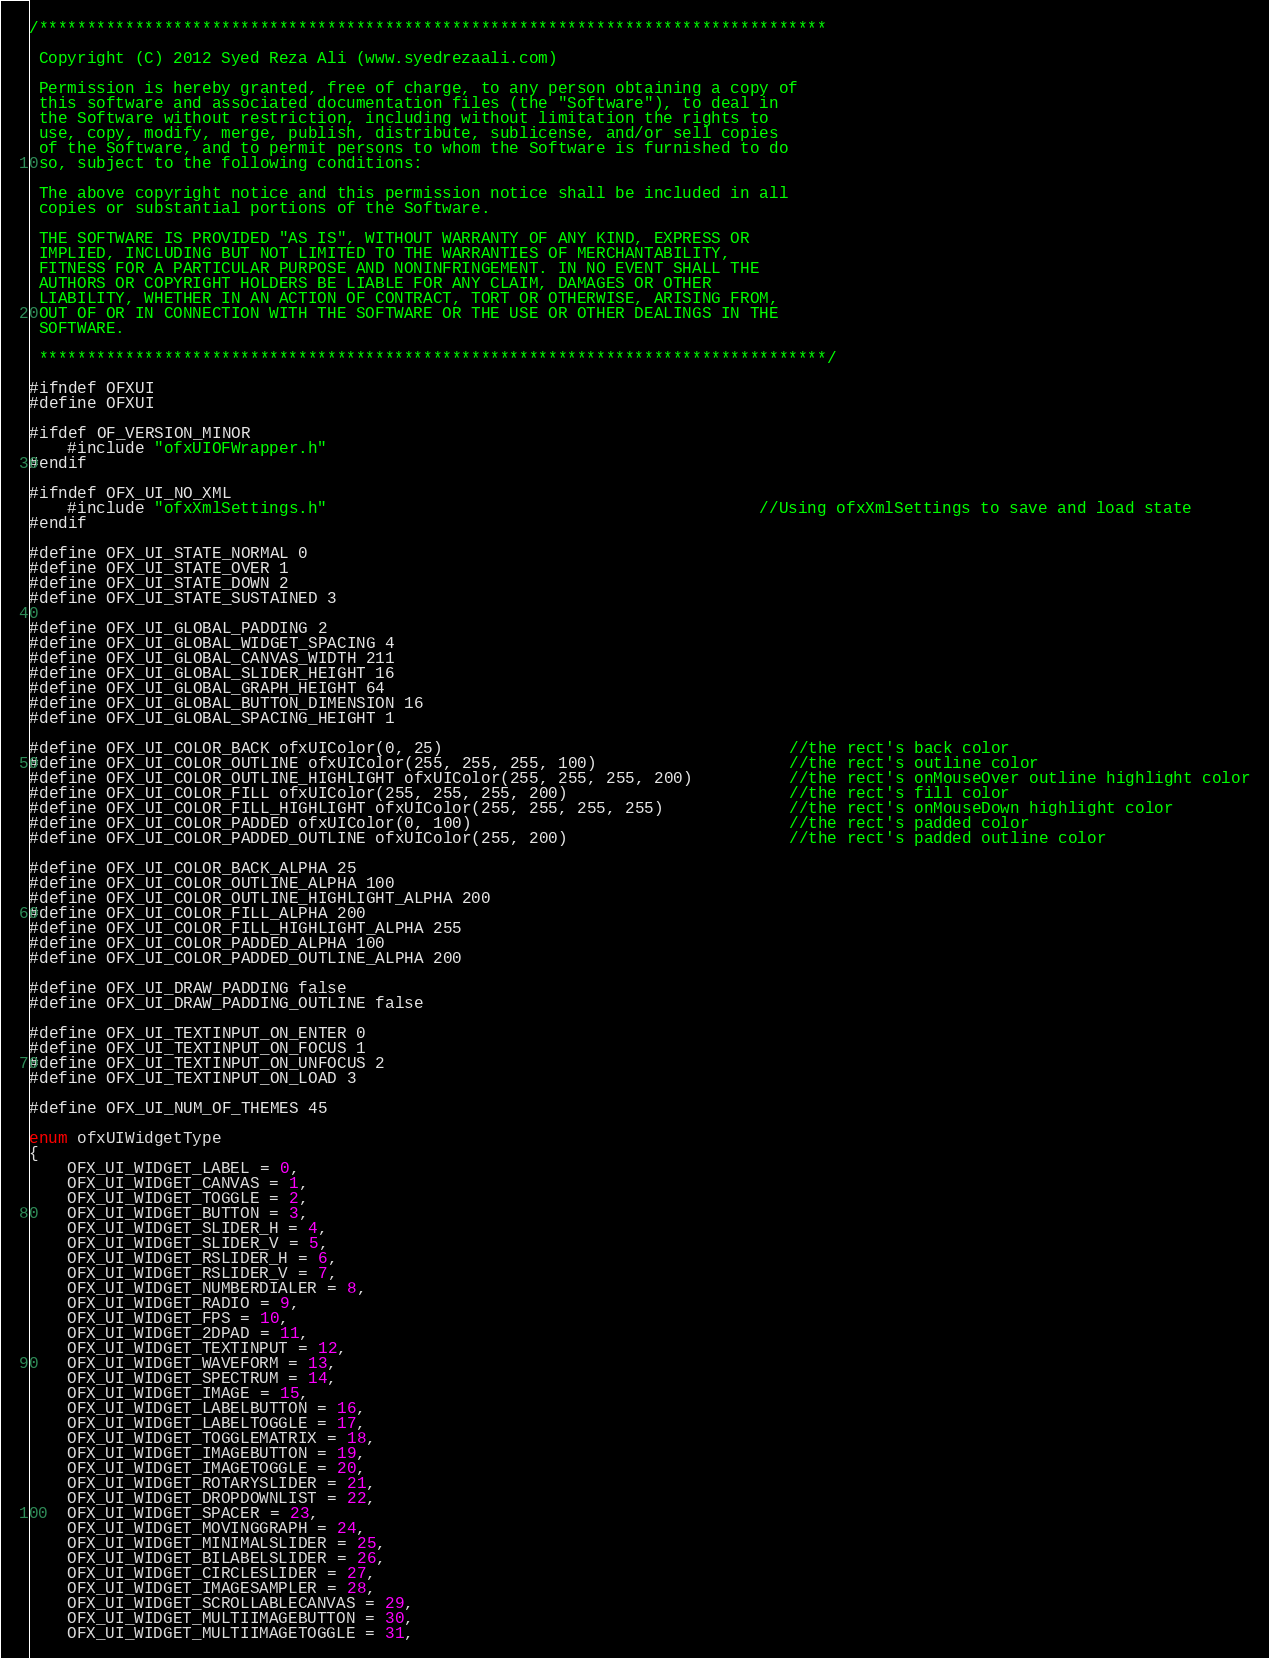Convert code to text. <code><loc_0><loc_0><loc_500><loc_500><_C_>/********************************************************************************** 
 
 Copyright (C) 2012 Syed Reza Ali (www.syedrezaali.com)
 
 Permission is hereby granted, free of charge, to any person obtaining a copy of
 this software and associated documentation files (the "Software"), to deal in
 the Software without restriction, including without limitation the rights to
 use, copy, modify, merge, publish, distribute, sublicense, and/or sell copies
 of the Software, and to permit persons to whom the Software is furnished to do
 so, subject to the following conditions:
 
 The above copyright notice and this permission notice shall be included in all
 copies or substantial portions of the Software.
 
 THE SOFTWARE IS PROVIDED "AS IS", WITHOUT WARRANTY OF ANY KIND, EXPRESS OR
 IMPLIED, INCLUDING BUT NOT LIMITED TO THE WARRANTIES OF MERCHANTABILITY,
 FITNESS FOR A PARTICULAR PURPOSE AND NONINFRINGEMENT. IN NO EVENT SHALL THE
 AUTHORS OR COPYRIGHT HOLDERS BE LIABLE FOR ANY CLAIM, DAMAGES OR OTHER
 LIABILITY, WHETHER IN AN ACTION OF CONTRACT, TORT OR OTHERWISE, ARISING FROM,
 OUT OF OR IN CONNECTION WITH THE SOFTWARE OR THE USE OR OTHER DEALINGS IN THE
 SOFTWARE.
 
 **********************************************************************************/

#ifndef OFXUI
#define OFXUI

#ifdef OF_VERSION_MINOR
    #include "ofxUIOFWrapper.h"
#endif

#ifndef OFX_UI_NO_XML
	#include "ofxXmlSettings.h"                                             //Using ofxXmlSettings to save and load state
#endif

#define OFX_UI_STATE_NORMAL 0
#define OFX_UI_STATE_OVER 1
#define OFX_UI_STATE_DOWN 2
#define OFX_UI_STATE_SUSTAINED 3

#define OFX_UI_GLOBAL_PADDING 2
#define OFX_UI_GLOBAL_WIDGET_SPACING 4
#define OFX_UI_GLOBAL_CANVAS_WIDTH 211
#define OFX_UI_GLOBAL_SLIDER_HEIGHT 16
#define OFX_UI_GLOBAL_GRAPH_HEIGHT 64
#define OFX_UI_GLOBAL_BUTTON_DIMENSION 16
#define OFX_UI_GLOBAL_SPACING_HEIGHT 1

#define OFX_UI_COLOR_BACK ofxUIColor(0, 25)                                    //the rect's back color
#define OFX_UI_COLOR_OUTLINE ofxUIColor(255, 255, 255, 100)                    //the rect's outline color
#define OFX_UI_COLOR_OUTLINE_HIGHLIGHT ofxUIColor(255, 255, 255, 200)          //the rect's onMouseOver outline highlight color
#define OFX_UI_COLOR_FILL ofxUIColor(255, 255, 255, 200)                       //the rect's fill color
#define OFX_UI_COLOR_FILL_HIGHLIGHT ofxUIColor(255, 255, 255, 255)             //the rect's onMouseDown highlight color
#define OFX_UI_COLOR_PADDED ofxUIColor(0, 100)                                 //the rect's padded color
#define OFX_UI_COLOR_PADDED_OUTLINE ofxUIColor(255, 200)                       //the rect's padded outline color

#define OFX_UI_COLOR_BACK_ALPHA 25
#define OFX_UI_COLOR_OUTLINE_ALPHA 100
#define OFX_UI_COLOR_OUTLINE_HIGHLIGHT_ALPHA 200
#define OFX_UI_COLOR_FILL_ALPHA 200
#define OFX_UI_COLOR_FILL_HIGHLIGHT_ALPHA 255
#define OFX_UI_COLOR_PADDED_ALPHA 100
#define OFX_UI_COLOR_PADDED_OUTLINE_ALPHA 200

#define OFX_UI_DRAW_PADDING false
#define OFX_UI_DRAW_PADDING_OUTLINE false

#define OFX_UI_TEXTINPUT_ON_ENTER 0 
#define OFX_UI_TEXTINPUT_ON_FOCUS 1 
#define OFX_UI_TEXTINPUT_ON_UNFOCUS 2
#define OFX_UI_TEXTINPUT_ON_LOAD 3

#define OFX_UI_NUM_OF_THEMES 45

enum ofxUIWidgetType
{
	OFX_UI_WIDGET_LABEL = 0,
	OFX_UI_WIDGET_CANVAS = 1,
	OFX_UI_WIDGET_TOGGLE = 2,
	OFX_UI_WIDGET_BUTTON = 3,
	OFX_UI_WIDGET_SLIDER_H = 4,
	OFX_UI_WIDGET_SLIDER_V = 5,
	OFX_UI_WIDGET_RSLIDER_H = 6,
	OFX_UI_WIDGET_RSLIDER_V = 7,	
	OFX_UI_WIDGET_NUMBERDIALER = 8,
	OFX_UI_WIDGET_RADIO = 9,
	OFX_UI_WIDGET_FPS = 10,
	OFX_UI_WIDGET_2DPAD = 11, 
	OFX_UI_WIDGET_TEXTINPUT = 12, 
	OFX_UI_WIDGET_WAVEFORM = 13,
	OFX_UI_WIDGET_SPECTRUM = 14,
	OFX_UI_WIDGET_IMAGE = 15, 
    OFX_UI_WIDGET_LABELBUTTON = 16, 
    OFX_UI_WIDGET_LABELTOGGLE = 17,
    OFX_UI_WIDGET_TOGGLEMATRIX = 18,
    OFX_UI_WIDGET_IMAGEBUTTON = 19, 
    OFX_UI_WIDGET_IMAGETOGGLE = 20,
    OFX_UI_WIDGET_ROTARYSLIDER = 21, 
    OFX_UI_WIDGET_DROPDOWNLIST = 22, 
    OFX_UI_WIDGET_SPACER = 23, 
    OFX_UI_WIDGET_MOVINGGRAPH = 24,
    OFX_UI_WIDGET_MINIMALSLIDER = 25,
    OFX_UI_WIDGET_BILABELSLIDER = 26,
    OFX_UI_WIDGET_CIRCLESLIDER = 27, 
    OFX_UI_WIDGET_IMAGESAMPLER = 28,
	OFX_UI_WIDGET_SCROLLABLECANVAS = 29, 
    OFX_UI_WIDGET_MULTIIMAGEBUTTON = 30,
    OFX_UI_WIDGET_MULTIIMAGETOGGLE = 31,</code> 